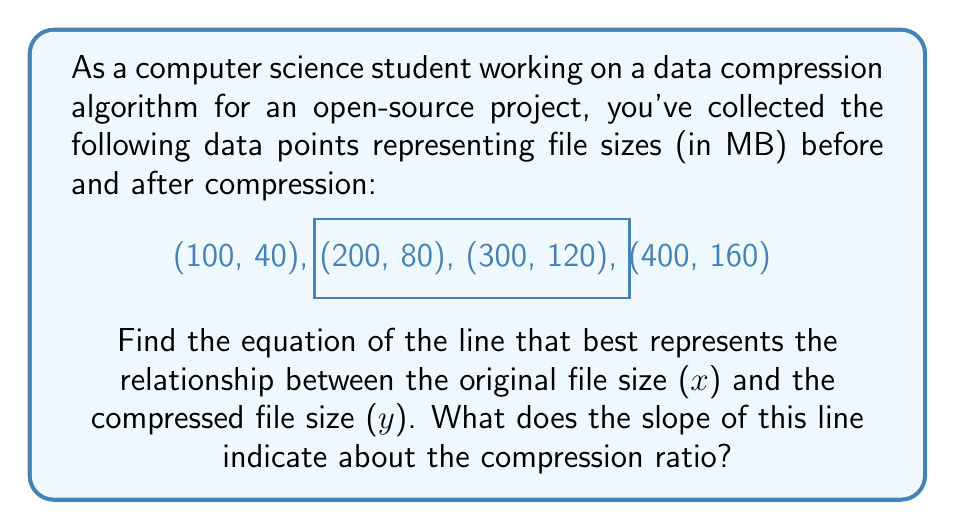Provide a solution to this math problem. Let's approach this step-by-step:

1) To find the equation of the line, we'll use the point-slope form: $y = mx + b$, where $m$ is the slope and $b$ is the y-intercept.

2) First, let's calculate the slope using two points. We'll use (100, 40) and (400, 160):

   $m = \frac{y_2 - y_1}{x_2 - x_1} = \frac{160 - 40}{400 - 100} = \frac{120}{300} = 0.4$

3) We can verify this slope using other pairs of points to ensure consistency.

4) Now that we have the slope, we can use any point to find the y-intercept. Let's use (100, 40):

   $40 = 0.4(100) + b$
   $40 = 40 + b$
   $b = 0$

5) Therefore, the equation of the line is:

   $y = 0.4x + 0$
   
   Which simplifies to:
   
   $y = 0.4x$

6) Interpretation of the slope:
   The slope of 0.4 indicates that for every increase of 1 MB in the original file size, the compressed file size increases by 0.4 MB.
   
   In terms of compression ratio:
   Compression Ratio = Original Size / Compressed Size = 1 / 0.4 = 2.5

   This means the compression algorithm achieves a 2.5:1 compression ratio, or it compresses files to 40% of their original size.
Answer: $y = 0.4x$; Slope indicates a 2.5:1 compression ratio. 